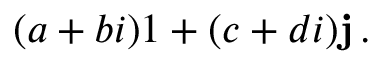<formula> <loc_0><loc_0><loc_500><loc_500>( a + b i ) 1 + ( c + d i ) j \, .</formula> 